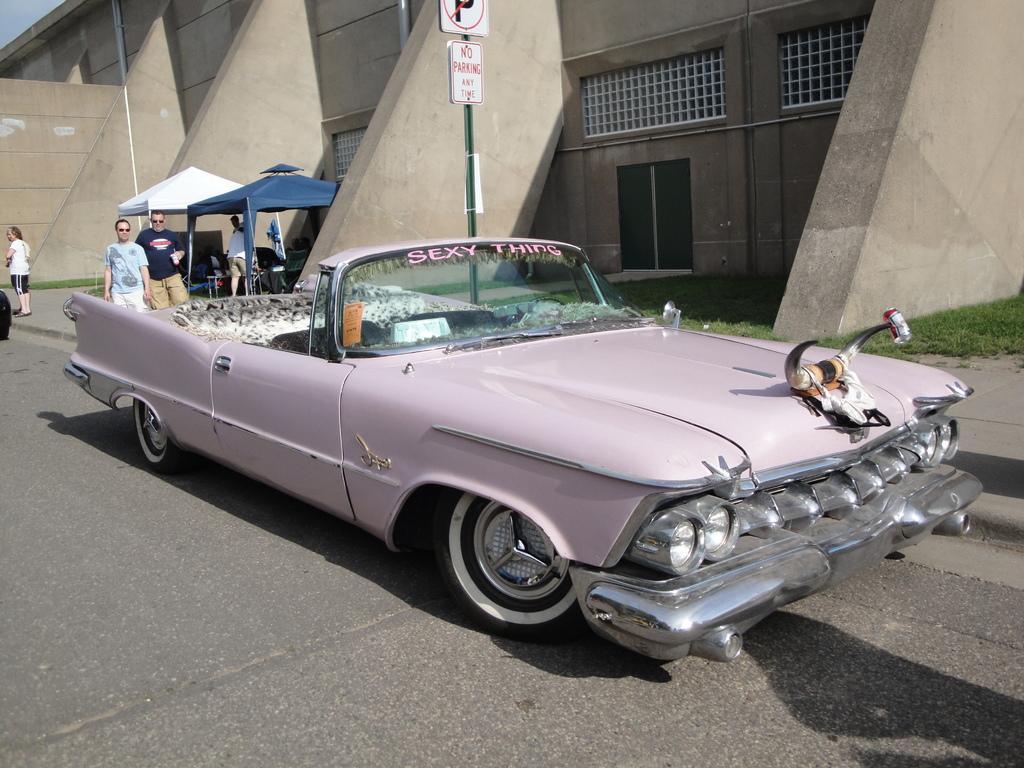Please provide a concise description of this image. In this image there is a car on the road. At the backside of the car there are persons standing on the road and we can see signal board beside the car. At the background there is a building. 